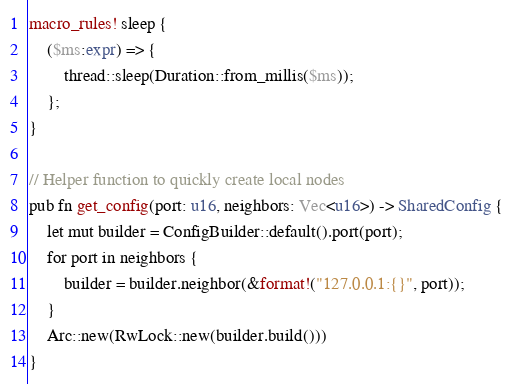Convert code to text. <code><loc_0><loc_0><loc_500><loc_500><_Rust_>macro_rules! sleep {
    ($ms:expr) => {
        thread::sleep(Duration::from_millis($ms));
    };
}

// Helper function to quickly create local nodes
pub fn get_config(port: u16, neighbors: Vec<u16>) -> SharedConfig {
    let mut builder = ConfigBuilder::default().port(port);
    for port in neighbors {
        builder = builder.neighbor(&format!("127.0.0.1:{}", port));
    }
    Arc::new(RwLock::new(builder.build()))
}
</code> 